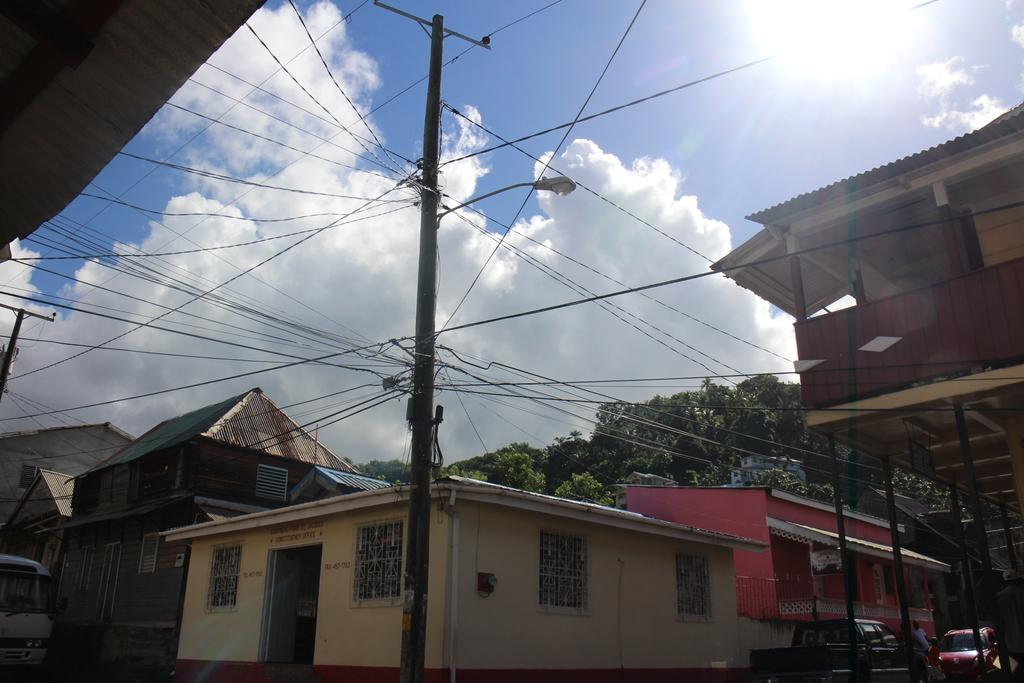What type of structures can be seen in the image? There are buildings in the image. What else is present in the image besides buildings? There are vehicles, persons on the ground, current poles with wires and light, and trees in the background. What can be seen in the sky in the image? The sky is visible in the background of the image. Can you tell me how many times the church bells have rung in the image? There is no church or church bells present in the image. What type of twist can be seen in the image? There is no twist or any object that can be twisted in the image. 